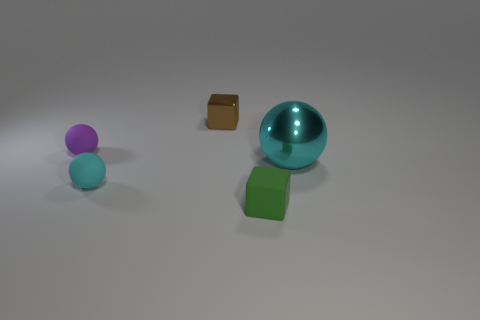What number of cyan metal things have the same size as the green rubber cube?
Offer a very short reply. 0. Is there a small rubber thing that is on the left side of the object on the right side of the small green object?
Offer a terse response. Yes. How many gray things are metallic cubes or matte cubes?
Provide a short and direct response. 0. The shiny sphere has what color?
Your answer should be very brief. Cyan. What is the size of the cyan ball that is the same material as the brown cube?
Give a very brief answer. Large. What number of cyan things have the same shape as the purple thing?
Offer a very short reply. 2. Are there any other things that have the same size as the cyan shiny sphere?
Offer a very short reply. No. What is the size of the cyan ball that is on the right side of the tiny rubber block that is to the right of the small brown metallic thing?
Offer a terse response. Large. What is the material of the green cube that is the same size as the purple rubber ball?
Offer a very short reply. Rubber. Is there a large thing made of the same material as the brown cube?
Your answer should be very brief. Yes. 